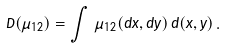Convert formula to latex. <formula><loc_0><loc_0><loc_500><loc_500>D ( \mu _ { 1 2 } ) = \int \, \mu _ { 1 2 } ( d x , d y ) \, d ( x , y ) \, .</formula> 